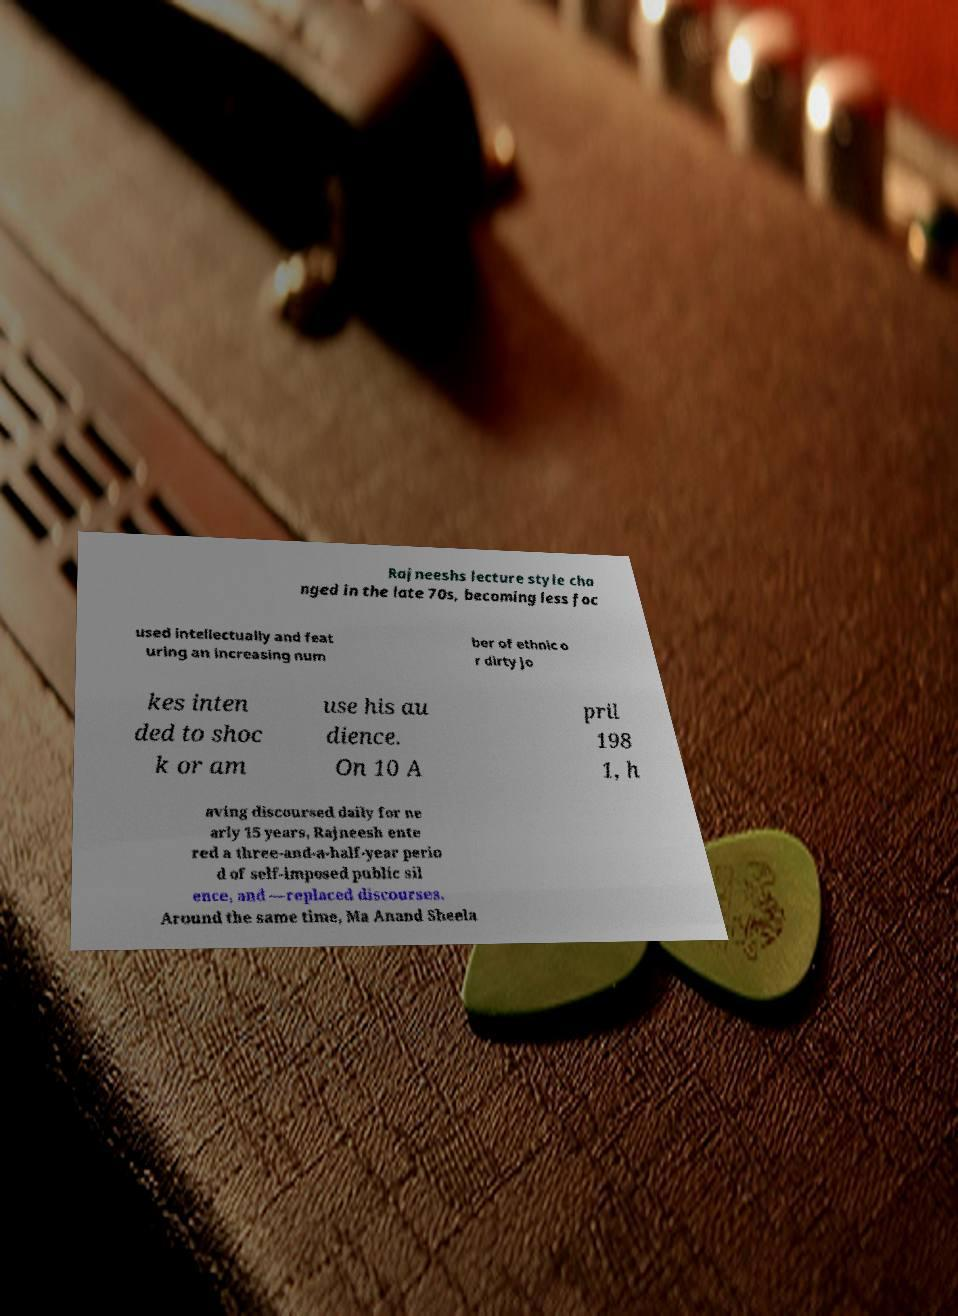Can you accurately transcribe the text from the provided image for me? Rajneeshs lecture style cha nged in the late 70s, becoming less foc used intellectually and feat uring an increasing num ber of ethnic o r dirty jo kes inten ded to shoc k or am use his au dience. On 10 A pril 198 1, h aving discoursed daily for ne arly 15 years, Rajneesh ente red a three-and-a-half-year perio d of self-imposed public sil ence, and —replaced discourses. Around the same time, Ma Anand Sheela 